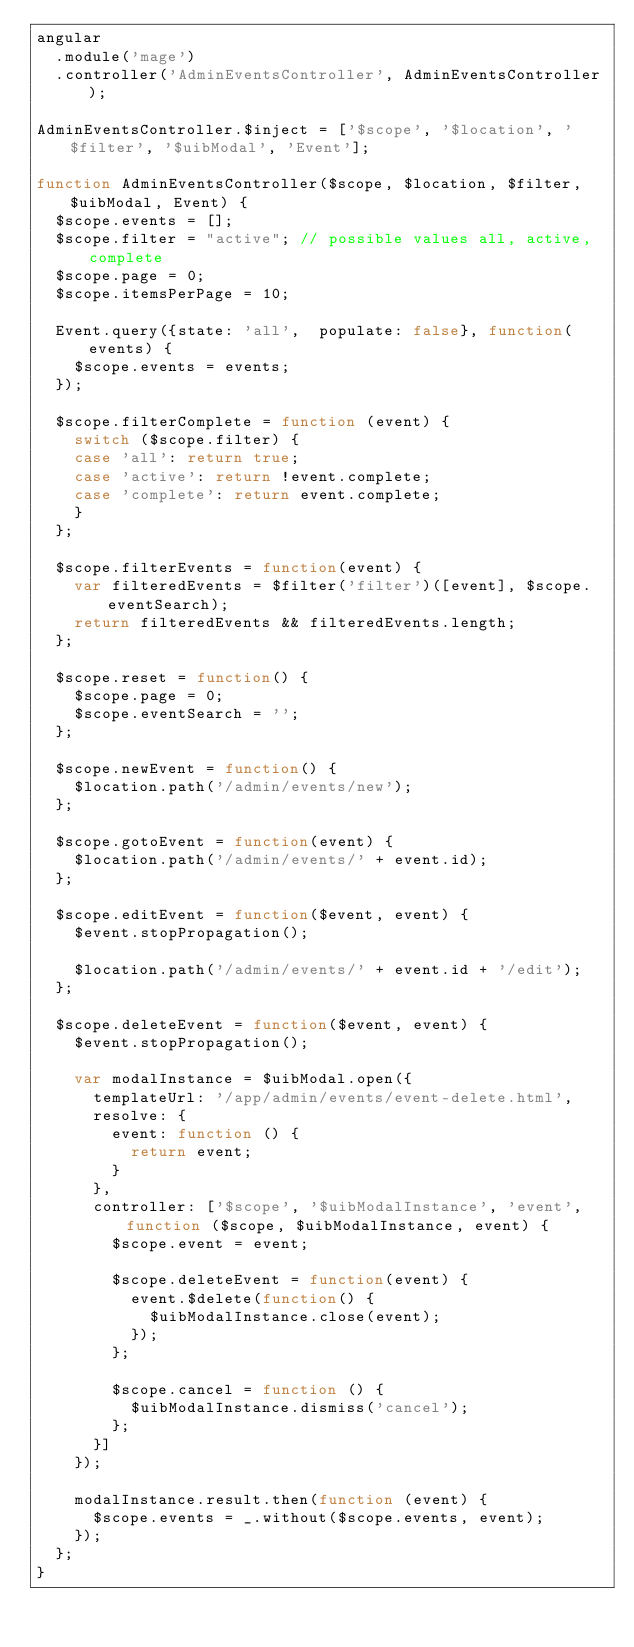Convert code to text. <code><loc_0><loc_0><loc_500><loc_500><_JavaScript_>angular
  .module('mage')
  .controller('AdminEventsController', AdminEventsController);

AdminEventsController.$inject = ['$scope', '$location', '$filter', '$uibModal', 'Event'];

function AdminEventsController($scope, $location, $filter, $uibModal, Event) {
  $scope.events = [];
  $scope.filter = "active"; // possible values all, active, complete
  $scope.page = 0;
  $scope.itemsPerPage = 10;

  Event.query({state: 'all',  populate: false}, function(events) {
    $scope.events = events;
  });

  $scope.filterComplete = function (event) {
    switch ($scope.filter) {
    case 'all': return true;
    case 'active': return !event.complete;
    case 'complete': return event.complete;
    }
  };

  $scope.filterEvents = function(event) {
    var filteredEvents = $filter('filter')([event], $scope.eventSearch);
    return filteredEvents && filteredEvents.length;
  };

  $scope.reset = function() {
    $scope.page = 0;
    $scope.eventSearch = '';
  };

  $scope.newEvent = function() {
    $location.path('/admin/events/new');
  };

  $scope.gotoEvent = function(event) {
    $location.path('/admin/events/' + event.id);
  };

  $scope.editEvent = function($event, event) {
    $event.stopPropagation();

    $location.path('/admin/events/' + event.id + '/edit');
  };

  $scope.deleteEvent = function($event, event) {
    $event.stopPropagation();

    var modalInstance = $uibModal.open({
      templateUrl: '/app/admin/events/event-delete.html',
      resolve: {
        event: function () {
          return event;
        }
      },
      controller: ['$scope', '$uibModalInstance', 'event', function ($scope, $uibModalInstance, event) {
        $scope.event = event;

        $scope.deleteEvent = function(event) {
          event.$delete(function() {
            $uibModalInstance.close(event);
          });
        };

        $scope.cancel = function () {
          $uibModalInstance.dismiss('cancel');
        };
      }]
    });

    modalInstance.result.then(function (event) {
      $scope.events = _.without($scope.events, event);
    });
  };
}
</code> 